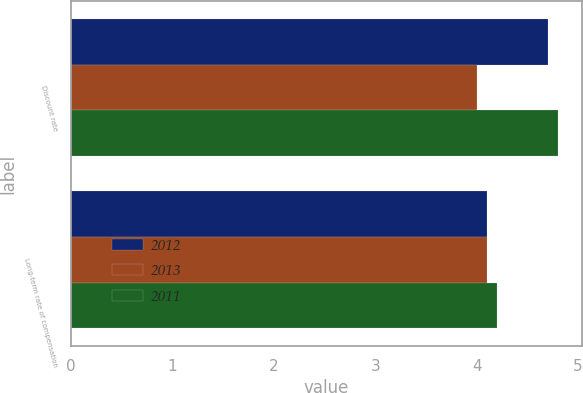<chart> <loc_0><loc_0><loc_500><loc_500><stacked_bar_chart><ecel><fcel>Discount rate<fcel>Long-term rate of compensation<nl><fcel>2012<fcel>4.7<fcel>4.1<nl><fcel>2013<fcel>4<fcel>4.1<nl><fcel>2011<fcel>4.8<fcel>4.2<nl></chart> 